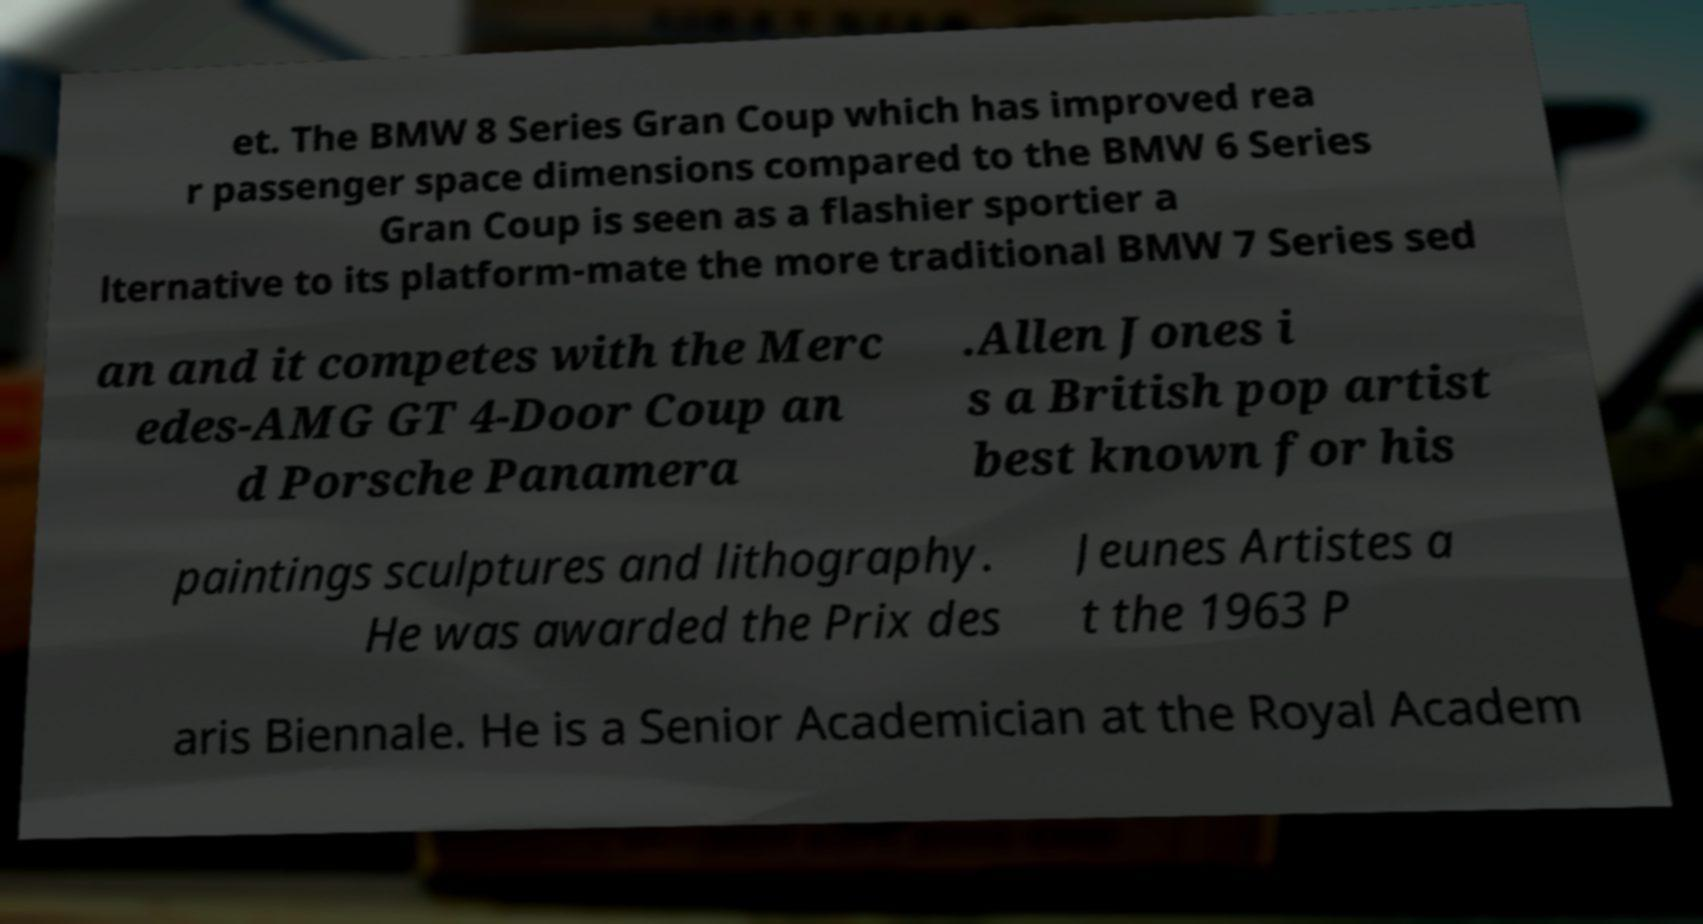Please identify and transcribe the text found in this image. et. The BMW 8 Series Gran Coup which has improved rea r passenger space dimensions compared to the BMW 6 Series Gran Coup is seen as a flashier sportier a lternative to its platform-mate the more traditional BMW 7 Series sed an and it competes with the Merc edes-AMG GT 4-Door Coup an d Porsche Panamera .Allen Jones i s a British pop artist best known for his paintings sculptures and lithography. He was awarded the Prix des Jeunes Artistes a t the 1963 P aris Biennale. He is a Senior Academician at the Royal Academ 